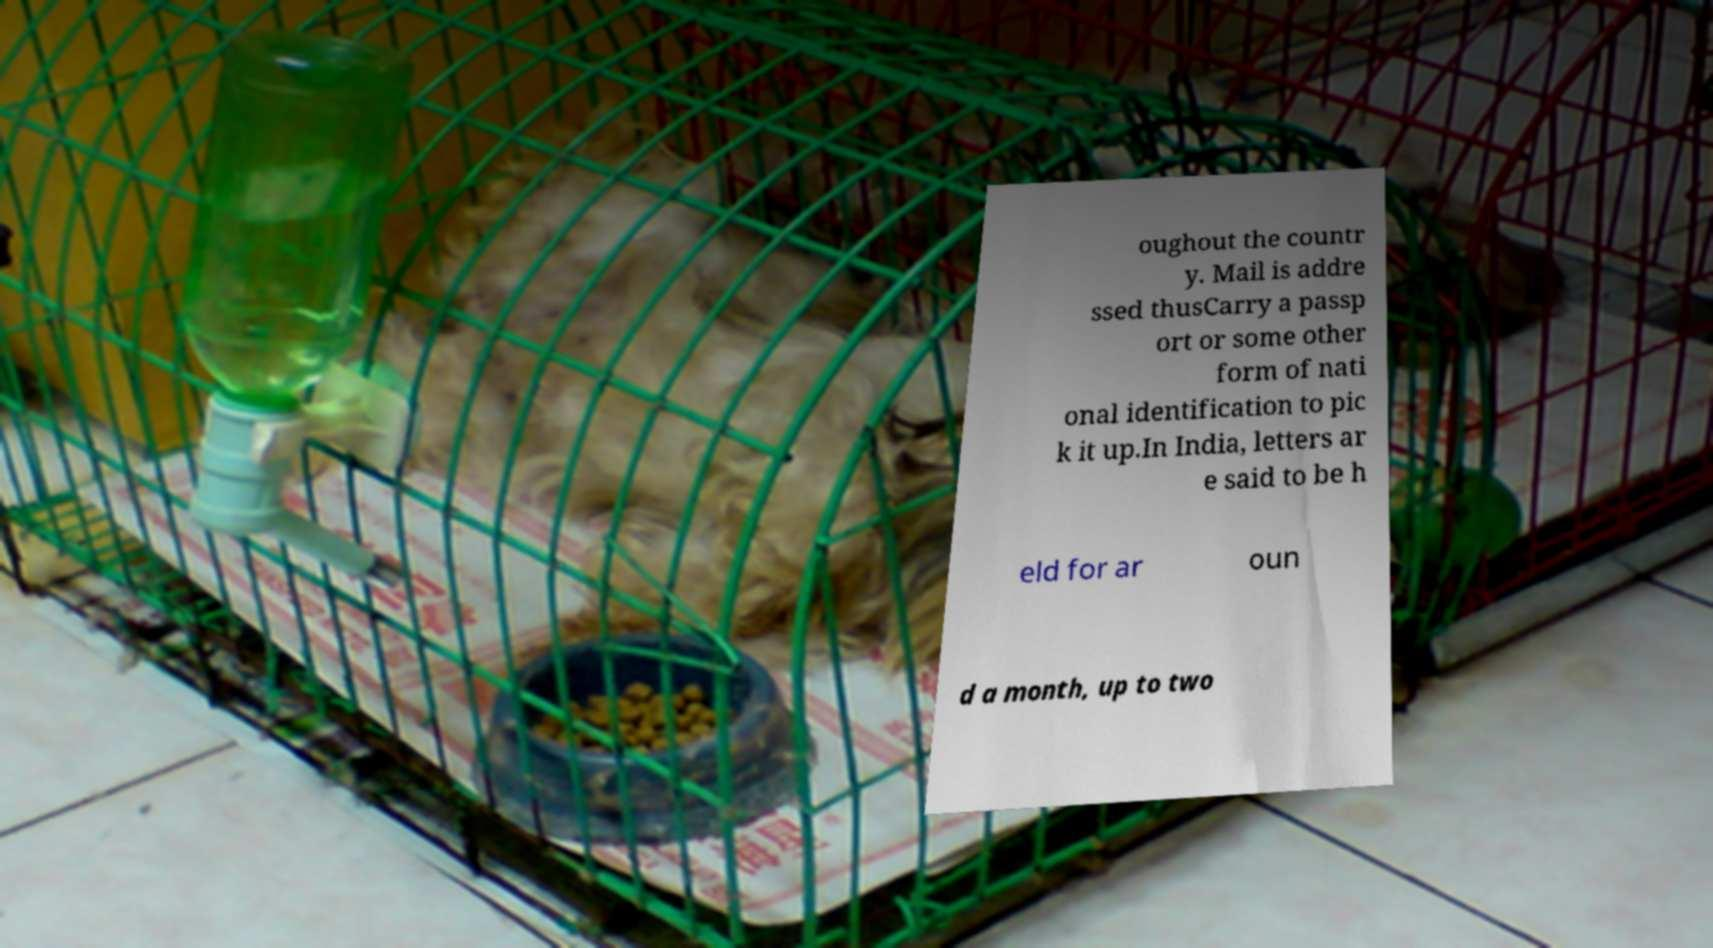Could you extract and type out the text from this image? oughout the countr y. Mail is addre ssed thusCarry a passp ort or some other form of nati onal identification to pic k it up.In India, letters ar e said to be h eld for ar oun d a month, up to two 